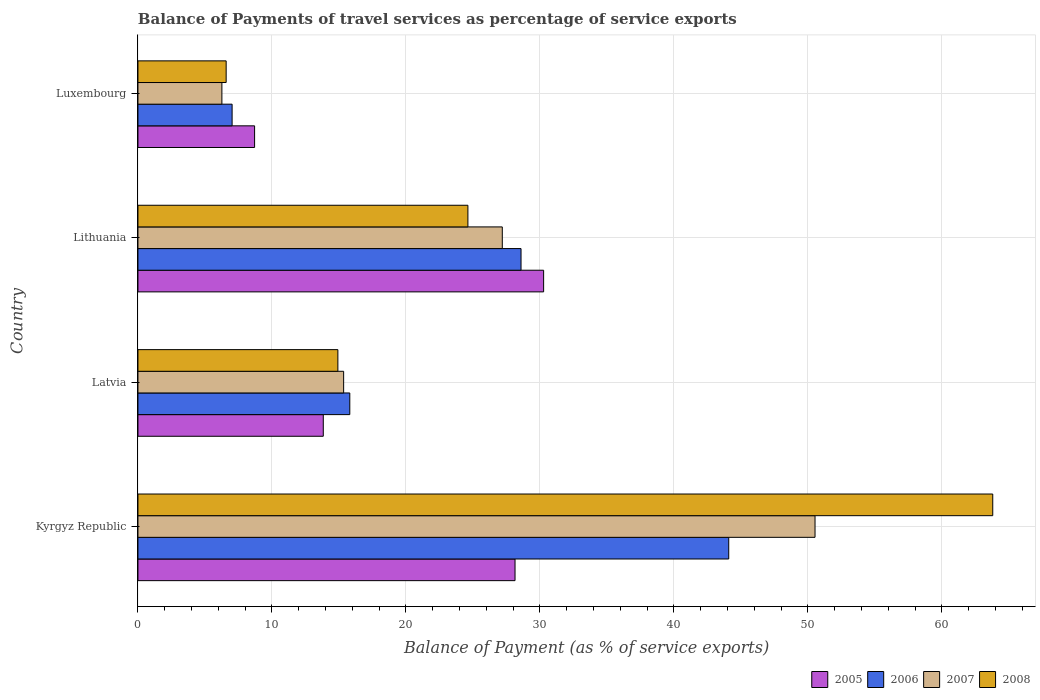How many groups of bars are there?
Provide a short and direct response. 4. What is the label of the 4th group of bars from the top?
Provide a short and direct response. Kyrgyz Republic. In how many cases, is the number of bars for a given country not equal to the number of legend labels?
Keep it short and to the point. 0. What is the balance of payments of travel services in 2008 in Lithuania?
Make the answer very short. 24.62. Across all countries, what is the maximum balance of payments of travel services in 2007?
Keep it short and to the point. 50.53. Across all countries, what is the minimum balance of payments of travel services in 2008?
Your answer should be very brief. 6.58. In which country was the balance of payments of travel services in 2007 maximum?
Offer a terse response. Kyrgyz Republic. In which country was the balance of payments of travel services in 2006 minimum?
Your answer should be compact. Luxembourg. What is the total balance of payments of travel services in 2005 in the graph?
Provide a short and direct response. 80.95. What is the difference between the balance of payments of travel services in 2005 in Latvia and that in Luxembourg?
Keep it short and to the point. 5.13. What is the difference between the balance of payments of travel services in 2006 in Kyrgyz Republic and the balance of payments of travel services in 2007 in Lithuania?
Provide a short and direct response. 16.9. What is the average balance of payments of travel services in 2008 per country?
Your response must be concise. 27.48. What is the difference between the balance of payments of travel services in 2008 and balance of payments of travel services in 2007 in Kyrgyz Republic?
Ensure brevity in your answer.  13.26. In how many countries, is the balance of payments of travel services in 2005 greater than 40 %?
Your response must be concise. 0. What is the ratio of the balance of payments of travel services in 2005 in Latvia to that in Lithuania?
Ensure brevity in your answer.  0.46. Is the balance of payments of travel services in 2006 in Lithuania less than that in Luxembourg?
Make the answer very short. No. Is the difference between the balance of payments of travel services in 2008 in Kyrgyz Republic and Latvia greater than the difference between the balance of payments of travel services in 2007 in Kyrgyz Republic and Latvia?
Offer a terse response. Yes. What is the difference between the highest and the second highest balance of payments of travel services in 2005?
Make the answer very short. 2.13. What is the difference between the highest and the lowest balance of payments of travel services in 2005?
Provide a short and direct response. 21.57. In how many countries, is the balance of payments of travel services in 2007 greater than the average balance of payments of travel services in 2007 taken over all countries?
Offer a very short reply. 2. Is the sum of the balance of payments of travel services in 2008 in Kyrgyz Republic and Latvia greater than the maximum balance of payments of travel services in 2006 across all countries?
Provide a succinct answer. Yes. What does the 2nd bar from the top in Lithuania represents?
Offer a terse response. 2007. What does the 2nd bar from the bottom in Kyrgyz Republic represents?
Your answer should be compact. 2006. How many bars are there?
Provide a short and direct response. 16. Are all the bars in the graph horizontal?
Make the answer very short. Yes. How many countries are there in the graph?
Give a very brief answer. 4. Are the values on the major ticks of X-axis written in scientific E-notation?
Give a very brief answer. No. Does the graph contain any zero values?
Offer a very short reply. No. Does the graph contain grids?
Ensure brevity in your answer.  Yes. Where does the legend appear in the graph?
Make the answer very short. Bottom right. What is the title of the graph?
Give a very brief answer. Balance of Payments of travel services as percentage of service exports. What is the label or title of the X-axis?
Provide a short and direct response. Balance of Payment (as % of service exports). What is the Balance of Payment (as % of service exports) in 2005 in Kyrgyz Republic?
Provide a short and direct response. 28.14. What is the Balance of Payment (as % of service exports) in 2006 in Kyrgyz Republic?
Provide a succinct answer. 44.09. What is the Balance of Payment (as % of service exports) in 2007 in Kyrgyz Republic?
Keep it short and to the point. 50.53. What is the Balance of Payment (as % of service exports) of 2008 in Kyrgyz Republic?
Offer a terse response. 63.79. What is the Balance of Payment (as % of service exports) in 2005 in Latvia?
Provide a succinct answer. 13.83. What is the Balance of Payment (as % of service exports) in 2006 in Latvia?
Provide a succinct answer. 15.81. What is the Balance of Payment (as % of service exports) in 2007 in Latvia?
Your answer should be compact. 15.35. What is the Balance of Payment (as % of service exports) in 2008 in Latvia?
Your answer should be compact. 14.92. What is the Balance of Payment (as % of service exports) of 2005 in Lithuania?
Provide a short and direct response. 30.28. What is the Balance of Payment (as % of service exports) of 2006 in Lithuania?
Offer a very short reply. 28.59. What is the Balance of Payment (as % of service exports) of 2007 in Lithuania?
Give a very brief answer. 27.19. What is the Balance of Payment (as % of service exports) in 2008 in Lithuania?
Ensure brevity in your answer.  24.62. What is the Balance of Payment (as % of service exports) of 2005 in Luxembourg?
Ensure brevity in your answer.  8.7. What is the Balance of Payment (as % of service exports) in 2006 in Luxembourg?
Provide a succinct answer. 7.03. What is the Balance of Payment (as % of service exports) of 2007 in Luxembourg?
Your answer should be very brief. 6.26. What is the Balance of Payment (as % of service exports) in 2008 in Luxembourg?
Your response must be concise. 6.58. Across all countries, what is the maximum Balance of Payment (as % of service exports) of 2005?
Your answer should be very brief. 30.28. Across all countries, what is the maximum Balance of Payment (as % of service exports) in 2006?
Provide a short and direct response. 44.09. Across all countries, what is the maximum Balance of Payment (as % of service exports) in 2007?
Ensure brevity in your answer.  50.53. Across all countries, what is the maximum Balance of Payment (as % of service exports) in 2008?
Give a very brief answer. 63.79. Across all countries, what is the minimum Balance of Payment (as % of service exports) of 2005?
Ensure brevity in your answer.  8.7. Across all countries, what is the minimum Balance of Payment (as % of service exports) in 2006?
Your answer should be compact. 7.03. Across all countries, what is the minimum Balance of Payment (as % of service exports) in 2007?
Provide a short and direct response. 6.26. Across all countries, what is the minimum Balance of Payment (as % of service exports) of 2008?
Your answer should be compact. 6.58. What is the total Balance of Payment (as % of service exports) in 2005 in the graph?
Keep it short and to the point. 80.95. What is the total Balance of Payment (as % of service exports) of 2006 in the graph?
Provide a succinct answer. 95.52. What is the total Balance of Payment (as % of service exports) in 2007 in the graph?
Provide a short and direct response. 99.34. What is the total Balance of Payment (as % of service exports) of 2008 in the graph?
Offer a very short reply. 109.92. What is the difference between the Balance of Payment (as % of service exports) of 2005 in Kyrgyz Republic and that in Latvia?
Your answer should be compact. 14.31. What is the difference between the Balance of Payment (as % of service exports) in 2006 in Kyrgyz Republic and that in Latvia?
Give a very brief answer. 28.28. What is the difference between the Balance of Payment (as % of service exports) of 2007 in Kyrgyz Republic and that in Latvia?
Your answer should be very brief. 35.18. What is the difference between the Balance of Payment (as % of service exports) of 2008 in Kyrgyz Republic and that in Latvia?
Make the answer very short. 48.87. What is the difference between the Balance of Payment (as % of service exports) of 2005 in Kyrgyz Republic and that in Lithuania?
Provide a short and direct response. -2.13. What is the difference between the Balance of Payment (as % of service exports) in 2006 in Kyrgyz Republic and that in Lithuania?
Ensure brevity in your answer.  15.5. What is the difference between the Balance of Payment (as % of service exports) of 2007 in Kyrgyz Republic and that in Lithuania?
Provide a succinct answer. 23.34. What is the difference between the Balance of Payment (as % of service exports) of 2008 in Kyrgyz Republic and that in Lithuania?
Provide a succinct answer. 39.17. What is the difference between the Balance of Payment (as % of service exports) in 2005 in Kyrgyz Republic and that in Luxembourg?
Offer a very short reply. 19.44. What is the difference between the Balance of Payment (as % of service exports) in 2006 in Kyrgyz Republic and that in Luxembourg?
Make the answer very short. 37.06. What is the difference between the Balance of Payment (as % of service exports) of 2007 in Kyrgyz Republic and that in Luxembourg?
Provide a short and direct response. 44.27. What is the difference between the Balance of Payment (as % of service exports) in 2008 in Kyrgyz Republic and that in Luxembourg?
Offer a very short reply. 57.21. What is the difference between the Balance of Payment (as % of service exports) in 2005 in Latvia and that in Lithuania?
Make the answer very short. -16.44. What is the difference between the Balance of Payment (as % of service exports) of 2006 in Latvia and that in Lithuania?
Offer a terse response. -12.78. What is the difference between the Balance of Payment (as % of service exports) of 2007 in Latvia and that in Lithuania?
Keep it short and to the point. -11.84. What is the difference between the Balance of Payment (as % of service exports) of 2008 in Latvia and that in Lithuania?
Keep it short and to the point. -9.7. What is the difference between the Balance of Payment (as % of service exports) of 2005 in Latvia and that in Luxembourg?
Keep it short and to the point. 5.13. What is the difference between the Balance of Payment (as % of service exports) of 2006 in Latvia and that in Luxembourg?
Provide a short and direct response. 8.78. What is the difference between the Balance of Payment (as % of service exports) in 2007 in Latvia and that in Luxembourg?
Provide a succinct answer. 9.09. What is the difference between the Balance of Payment (as % of service exports) in 2008 in Latvia and that in Luxembourg?
Your answer should be compact. 8.34. What is the difference between the Balance of Payment (as % of service exports) of 2005 in Lithuania and that in Luxembourg?
Make the answer very short. 21.57. What is the difference between the Balance of Payment (as % of service exports) of 2006 in Lithuania and that in Luxembourg?
Your response must be concise. 21.56. What is the difference between the Balance of Payment (as % of service exports) in 2007 in Lithuania and that in Luxembourg?
Offer a very short reply. 20.93. What is the difference between the Balance of Payment (as % of service exports) in 2008 in Lithuania and that in Luxembourg?
Your response must be concise. 18.04. What is the difference between the Balance of Payment (as % of service exports) of 2005 in Kyrgyz Republic and the Balance of Payment (as % of service exports) of 2006 in Latvia?
Offer a terse response. 12.33. What is the difference between the Balance of Payment (as % of service exports) of 2005 in Kyrgyz Republic and the Balance of Payment (as % of service exports) of 2007 in Latvia?
Your response must be concise. 12.79. What is the difference between the Balance of Payment (as % of service exports) in 2005 in Kyrgyz Republic and the Balance of Payment (as % of service exports) in 2008 in Latvia?
Your answer should be compact. 13.22. What is the difference between the Balance of Payment (as % of service exports) in 2006 in Kyrgyz Republic and the Balance of Payment (as % of service exports) in 2007 in Latvia?
Provide a short and direct response. 28.74. What is the difference between the Balance of Payment (as % of service exports) of 2006 in Kyrgyz Republic and the Balance of Payment (as % of service exports) of 2008 in Latvia?
Your answer should be compact. 29.17. What is the difference between the Balance of Payment (as % of service exports) of 2007 in Kyrgyz Republic and the Balance of Payment (as % of service exports) of 2008 in Latvia?
Ensure brevity in your answer.  35.61. What is the difference between the Balance of Payment (as % of service exports) of 2005 in Kyrgyz Republic and the Balance of Payment (as % of service exports) of 2006 in Lithuania?
Give a very brief answer. -0.45. What is the difference between the Balance of Payment (as % of service exports) in 2005 in Kyrgyz Republic and the Balance of Payment (as % of service exports) in 2007 in Lithuania?
Make the answer very short. 0.95. What is the difference between the Balance of Payment (as % of service exports) in 2005 in Kyrgyz Republic and the Balance of Payment (as % of service exports) in 2008 in Lithuania?
Offer a very short reply. 3.52. What is the difference between the Balance of Payment (as % of service exports) of 2006 in Kyrgyz Republic and the Balance of Payment (as % of service exports) of 2007 in Lithuania?
Give a very brief answer. 16.9. What is the difference between the Balance of Payment (as % of service exports) of 2006 in Kyrgyz Republic and the Balance of Payment (as % of service exports) of 2008 in Lithuania?
Your answer should be very brief. 19.47. What is the difference between the Balance of Payment (as % of service exports) of 2007 in Kyrgyz Republic and the Balance of Payment (as % of service exports) of 2008 in Lithuania?
Offer a very short reply. 25.91. What is the difference between the Balance of Payment (as % of service exports) in 2005 in Kyrgyz Republic and the Balance of Payment (as % of service exports) in 2006 in Luxembourg?
Ensure brevity in your answer.  21.12. What is the difference between the Balance of Payment (as % of service exports) of 2005 in Kyrgyz Republic and the Balance of Payment (as % of service exports) of 2007 in Luxembourg?
Provide a succinct answer. 21.88. What is the difference between the Balance of Payment (as % of service exports) in 2005 in Kyrgyz Republic and the Balance of Payment (as % of service exports) in 2008 in Luxembourg?
Give a very brief answer. 21.56. What is the difference between the Balance of Payment (as % of service exports) of 2006 in Kyrgyz Republic and the Balance of Payment (as % of service exports) of 2007 in Luxembourg?
Offer a very short reply. 37.83. What is the difference between the Balance of Payment (as % of service exports) of 2006 in Kyrgyz Republic and the Balance of Payment (as % of service exports) of 2008 in Luxembourg?
Your answer should be compact. 37.51. What is the difference between the Balance of Payment (as % of service exports) in 2007 in Kyrgyz Republic and the Balance of Payment (as % of service exports) in 2008 in Luxembourg?
Your response must be concise. 43.95. What is the difference between the Balance of Payment (as % of service exports) in 2005 in Latvia and the Balance of Payment (as % of service exports) in 2006 in Lithuania?
Provide a succinct answer. -14.76. What is the difference between the Balance of Payment (as % of service exports) of 2005 in Latvia and the Balance of Payment (as % of service exports) of 2007 in Lithuania?
Your answer should be compact. -13.36. What is the difference between the Balance of Payment (as % of service exports) of 2005 in Latvia and the Balance of Payment (as % of service exports) of 2008 in Lithuania?
Your answer should be very brief. -10.79. What is the difference between the Balance of Payment (as % of service exports) in 2006 in Latvia and the Balance of Payment (as % of service exports) in 2007 in Lithuania?
Offer a very short reply. -11.38. What is the difference between the Balance of Payment (as % of service exports) in 2006 in Latvia and the Balance of Payment (as % of service exports) in 2008 in Lithuania?
Provide a short and direct response. -8.81. What is the difference between the Balance of Payment (as % of service exports) of 2007 in Latvia and the Balance of Payment (as % of service exports) of 2008 in Lithuania?
Offer a terse response. -9.27. What is the difference between the Balance of Payment (as % of service exports) of 2005 in Latvia and the Balance of Payment (as % of service exports) of 2006 in Luxembourg?
Offer a terse response. 6.81. What is the difference between the Balance of Payment (as % of service exports) in 2005 in Latvia and the Balance of Payment (as % of service exports) in 2007 in Luxembourg?
Offer a terse response. 7.57. What is the difference between the Balance of Payment (as % of service exports) of 2005 in Latvia and the Balance of Payment (as % of service exports) of 2008 in Luxembourg?
Give a very brief answer. 7.25. What is the difference between the Balance of Payment (as % of service exports) of 2006 in Latvia and the Balance of Payment (as % of service exports) of 2007 in Luxembourg?
Provide a succinct answer. 9.55. What is the difference between the Balance of Payment (as % of service exports) in 2006 in Latvia and the Balance of Payment (as % of service exports) in 2008 in Luxembourg?
Give a very brief answer. 9.23. What is the difference between the Balance of Payment (as % of service exports) in 2007 in Latvia and the Balance of Payment (as % of service exports) in 2008 in Luxembourg?
Offer a terse response. 8.77. What is the difference between the Balance of Payment (as % of service exports) in 2005 in Lithuania and the Balance of Payment (as % of service exports) in 2006 in Luxembourg?
Make the answer very short. 23.25. What is the difference between the Balance of Payment (as % of service exports) in 2005 in Lithuania and the Balance of Payment (as % of service exports) in 2007 in Luxembourg?
Provide a short and direct response. 24.01. What is the difference between the Balance of Payment (as % of service exports) in 2005 in Lithuania and the Balance of Payment (as % of service exports) in 2008 in Luxembourg?
Offer a terse response. 23.69. What is the difference between the Balance of Payment (as % of service exports) in 2006 in Lithuania and the Balance of Payment (as % of service exports) in 2007 in Luxembourg?
Your answer should be compact. 22.32. What is the difference between the Balance of Payment (as % of service exports) in 2006 in Lithuania and the Balance of Payment (as % of service exports) in 2008 in Luxembourg?
Keep it short and to the point. 22.01. What is the difference between the Balance of Payment (as % of service exports) of 2007 in Lithuania and the Balance of Payment (as % of service exports) of 2008 in Luxembourg?
Your response must be concise. 20.61. What is the average Balance of Payment (as % of service exports) in 2005 per country?
Provide a succinct answer. 20.24. What is the average Balance of Payment (as % of service exports) in 2006 per country?
Your response must be concise. 23.88. What is the average Balance of Payment (as % of service exports) of 2007 per country?
Provide a short and direct response. 24.83. What is the average Balance of Payment (as % of service exports) in 2008 per country?
Ensure brevity in your answer.  27.48. What is the difference between the Balance of Payment (as % of service exports) of 2005 and Balance of Payment (as % of service exports) of 2006 in Kyrgyz Republic?
Offer a terse response. -15.95. What is the difference between the Balance of Payment (as % of service exports) of 2005 and Balance of Payment (as % of service exports) of 2007 in Kyrgyz Republic?
Provide a succinct answer. -22.39. What is the difference between the Balance of Payment (as % of service exports) of 2005 and Balance of Payment (as % of service exports) of 2008 in Kyrgyz Republic?
Give a very brief answer. -35.65. What is the difference between the Balance of Payment (as % of service exports) of 2006 and Balance of Payment (as % of service exports) of 2007 in Kyrgyz Republic?
Your response must be concise. -6.44. What is the difference between the Balance of Payment (as % of service exports) of 2006 and Balance of Payment (as % of service exports) of 2008 in Kyrgyz Republic?
Offer a very short reply. -19.7. What is the difference between the Balance of Payment (as % of service exports) in 2007 and Balance of Payment (as % of service exports) in 2008 in Kyrgyz Republic?
Provide a short and direct response. -13.26. What is the difference between the Balance of Payment (as % of service exports) of 2005 and Balance of Payment (as % of service exports) of 2006 in Latvia?
Your answer should be compact. -1.98. What is the difference between the Balance of Payment (as % of service exports) of 2005 and Balance of Payment (as % of service exports) of 2007 in Latvia?
Ensure brevity in your answer.  -1.52. What is the difference between the Balance of Payment (as % of service exports) in 2005 and Balance of Payment (as % of service exports) in 2008 in Latvia?
Ensure brevity in your answer.  -1.09. What is the difference between the Balance of Payment (as % of service exports) in 2006 and Balance of Payment (as % of service exports) in 2007 in Latvia?
Keep it short and to the point. 0.46. What is the difference between the Balance of Payment (as % of service exports) in 2006 and Balance of Payment (as % of service exports) in 2008 in Latvia?
Your answer should be very brief. 0.89. What is the difference between the Balance of Payment (as % of service exports) of 2007 and Balance of Payment (as % of service exports) of 2008 in Latvia?
Provide a short and direct response. 0.43. What is the difference between the Balance of Payment (as % of service exports) in 2005 and Balance of Payment (as % of service exports) in 2006 in Lithuania?
Make the answer very short. 1.69. What is the difference between the Balance of Payment (as % of service exports) in 2005 and Balance of Payment (as % of service exports) in 2007 in Lithuania?
Your response must be concise. 3.08. What is the difference between the Balance of Payment (as % of service exports) in 2005 and Balance of Payment (as % of service exports) in 2008 in Lithuania?
Offer a terse response. 5.65. What is the difference between the Balance of Payment (as % of service exports) in 2006 and Balance of Payment (as % of service exports) in 2007 in Lithuania?
Make the answer very short. 1.4. What is the difference between the Balance of Payment (as % of service exports) of 2006 and Balance of Payment (as % of service exports) of 2008 in Lithuania?
Provide a short and direct response. 3.96. What is the difference between the Balance of Payment (as % of service exports) in 2007 and Balance of Payment (as % of service exports) in 2008 in Lithuania?
Your response must be concise. 2.57. What is the difference between the Balance of Payment (as % of service exports) of 2005 and Balance of Payment (as % of service exports) of 2006 in Luxembourg?
Offer a very short reply. 1.68. What is the difference between the Balance of Payment (as % of service exports) of 2005 and Balance of Payment (as % of service exports) of 2007 in Luxembourg?
Your answer should be very brief. 2.44. What is the difference between the Balance of Payment (as % of service exports) in 2005 and Balance of Payment (as % of service exports) in 2008 in Luxembourg?
Give a very brief answer. 2.12. What is the difference between the Balance of Payment (as % of service exports) of 2006 and Balance of Payment (as % of service exports) of 2007 in Luxembourg?
Offer a very short reply. 0.76. What is the difference between the Balance of Payment (as % of service exports) in 2006 and Balance of Payment (as % of service exports) in 2008 in Luxembourg?
Your answer should be compact. 0.44. What is the difference between the Balance of Payment (as % of service exports) in 2007 and Balance of Payment (as % of service exports) in 2008 in Luxembourg?
Provide a short and direct response. -0.32. What is the ratio of the Balance of Payment (as % of service exports) in 2005 in Kyrgyz Republic to that in Latvia?
Keep it short and to the point. 2.03. What is the ratio of the Balance of Payment (as % of service exports) of 2006 in Kyrgyz Republic to that in Latvia?
Keep it short and to the point. 2.79. What is the ratio of the Balance of Payment (as % of service exports) in 2007 in Kyrgyz Republic to that in Latvia?
Keep it short and to the point. 3.29. What is the ratio of the Balance of Payment (as % of service exports) of 2008 in Kyrgyz Republic to that in Latvia?
Offer a very short reply. 4.28. What is the ratio of the Balance of Payment (as % of service exports) in 2005 in Kyrgyz Republic to that in Lithuania?
Make the answer very short. 0.93. What is the ratio of the Balance of Payment (as % of service exports) of 2006 in Kyrgyz Republic to that in Lithuania?
Provide a succinct answer. 1.54. What is the ratio of the Balance of Payment (as % of service exports) in 2007 in Kyrgyz Republic to that in Lithuania?
Offer a very short reply. 1.86. What is the ratio of the Balance of Payment (as % of service exports) in 2008 in Kyrgyz Republic to that in Lithuania?
Keep it short and to the point. 2.59. What is the ratio of the Balance of Payment (as % of service exports) of 2005 in Kyrgyz Republic to that in Luxembourg?
Keep it short and to the point. 3.23. What is the ratio of the Balance of Payment (as % of service exports) in 2006 in Kyrgyz Republic to that in Luxembourg?
Your answer should be compact. 6.28. What is the ratio of the Balance of Payment (as % of service exports) of 2007 in Kyrgyz Republic to that in Luxembourg?
Provide a succinct answer. 8.07. What is the ratio of the Balance of Payment (as % of service exports) in 2008 in Kyrgyz Republic to that in Luxembourg?
Give a very brief answer. 9.69. What is the ratio of the Balance of Payment (as % of service exports) of 2005 in Latvia to that in Lithuania?
Make the answer very short. 0.46. What is the ratio of the Balance of Payment (as % of service exports) in 2006 in Latvia to that in Lithuania?
Your answer should be compact. 0.55. What is the ratio of the Balance of Payment (as % of service exports) of 2007 in Latvia to that in Lithuania?
Your answer should be very brief. 0.56. What is the ratio of the Balance of Payment (as % of service exports) of 2008 in Latvia to that in Lithuania?
Provide a succinct answer. 0.61. What is the ratio of the Balance of Payment (as % of service exports) in 2005 in Latvia to that in Luxembourg?
Keep it short and to the point. 1.59. What is the ratio of the Balance of Payment (as % of service exports) in 2006 in Latvia to that in Luxembourg?
Offer a very short reply. 2.25. What is the ratio of the Balance of Payment (as % of service exports) in 2007 in Latvia to that in Luxembourg?
Provide a succinct answer. 2.45. What is the ratio of the Balance of Payment (as % of service exports) in 2008 in Latvia to that in Luxembourg?
Make the answer very short. 2.27. What is the ratio of the Balance of Payment (as % of service exports) in 2005 in Lithuania to that in Luxembourg?
Give a very brief answer. 3.48. What is the ratio of the Balance of Payment (as % of service exports) of 2006 in Lithuania to that in Luxembourg?
Provide a short and direct response. 4.07. What is the ratio of the Balance of Payment (as % of service exports) in 2007 in Lithuania to that in Luxembourg?
Make the answer very short. 4.34. What is the ratio of the Balance of Payment (as % of service exports) in 2008 in Lithuania to that in Luxembourg?
Make the answer very short. 3.74. What is the difference between the highest and the second highest Balance of Payment (as % of service exports) in 2005?
Offer a very short reply. 2.13. What is the difference between the highest and the second highest Balance of Payment (as % of service exports) in 2006?
Offer a terse response. 15.5. What is the difference between the highest and the second highest Balance of Payment (as % of service exports) in 2007?
Your answer should be very brief. 23.34. What is the difference between the highest and the second highest Balance of Payment (as % of service exports) in 2008?
Your answer should be compact. 39.17. What is the difference between the highest and the lowest Balance of Payment (as % of service exports) in 2005?
Keep it short and to the point. 21.57. What is the difference between the highest and the lowest Balance of Payment (as % of service exports) of 2006?
Provide a short and direct response. 37.06. What is the difference between the highest and the lowest Balance of Payment (as % of service exports) of 2007?
Ensure brevity in your answer.  44.27. What is the difference between the highest and the lowest Balance of Payment (as % of service exports) of 2008?
Provide a succinct answer. 57.21. 